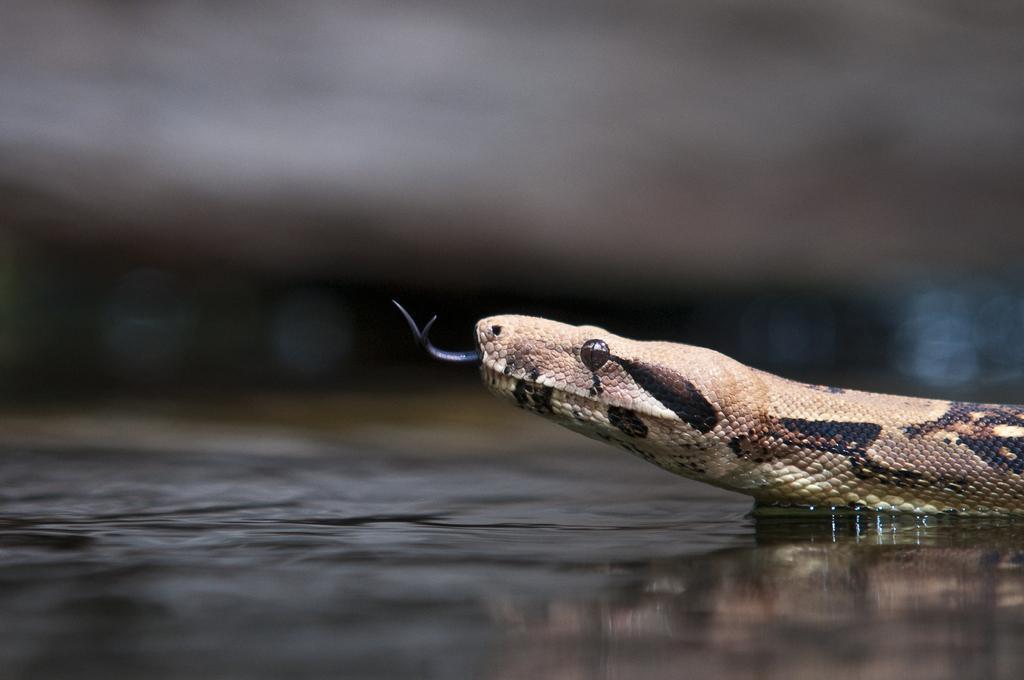In one or two sentences, can you explain what this image depicts? In this image we can see a snake on the ground, here is the tongue, here is the eye. 